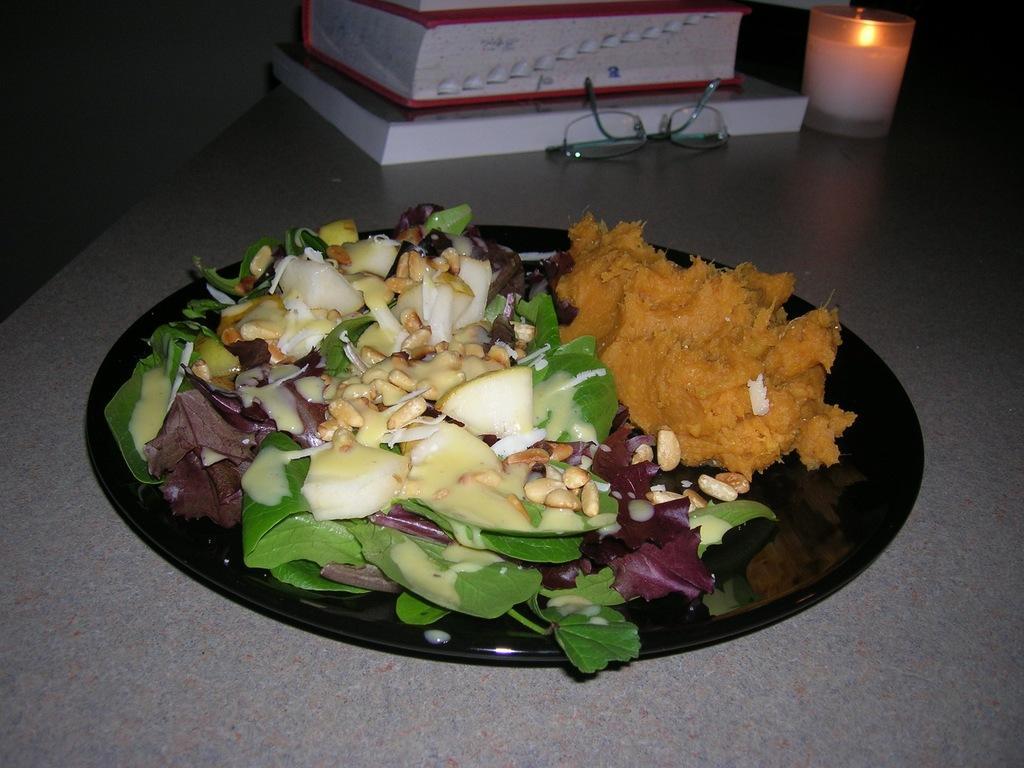Can you describe this image briefly? In the picture I can see some food items is kept on the black color plate, I can see books, spectacles and a candle are kept on the surface. 